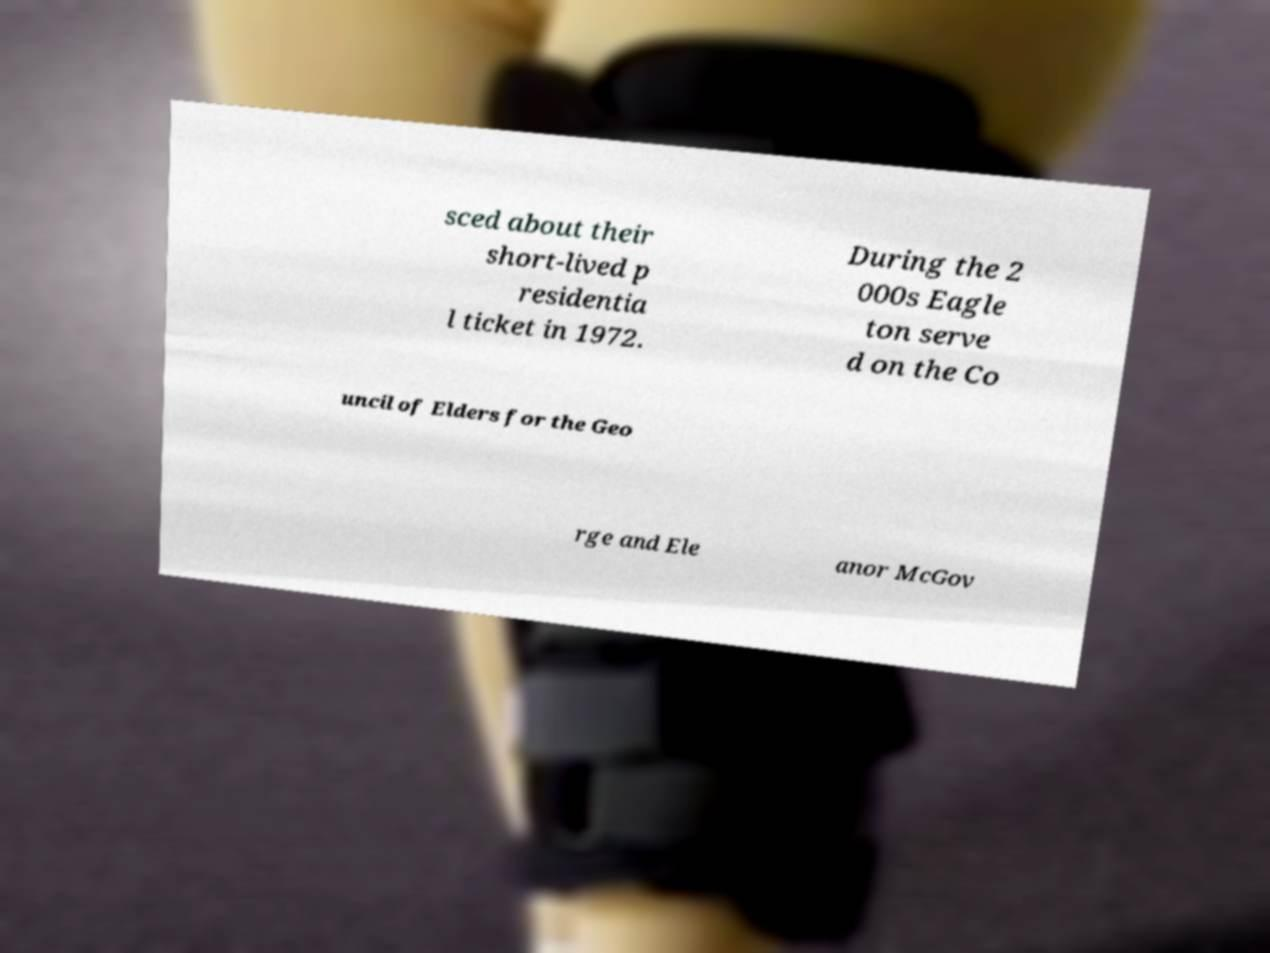Could you extract and type out the text from this image? sced about their short-lived p residentia l ticket in 1972. During the 2 000s Eagle ton serve d on the Co uncil of Elders for the Geo rge and Ele anor McGov 